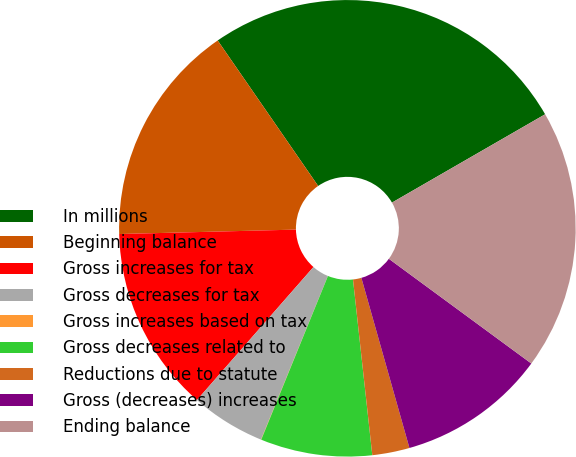<chart> <loc_0><loc_0><loc_500><loc_500><pie_chart><fcel>In millions<fcel>Beginning balance<fcel>Gross increases for tax<fcel>Gross decreases for tax<fcel>Gross increases based on tax<fcel>Gross decreases related to<fcel>Reductions due to statute<fcel>Gross (decreases) increases<fcel>Ending balance<nl><fcel>26.29%<fcel>15.78%<fcel>13.15%<fcel>5.27%<fcel>0.02%<fcel>7.9%<fcel>2.64%<fcel>10.53%<fcel>18.41%<nl></chart> 